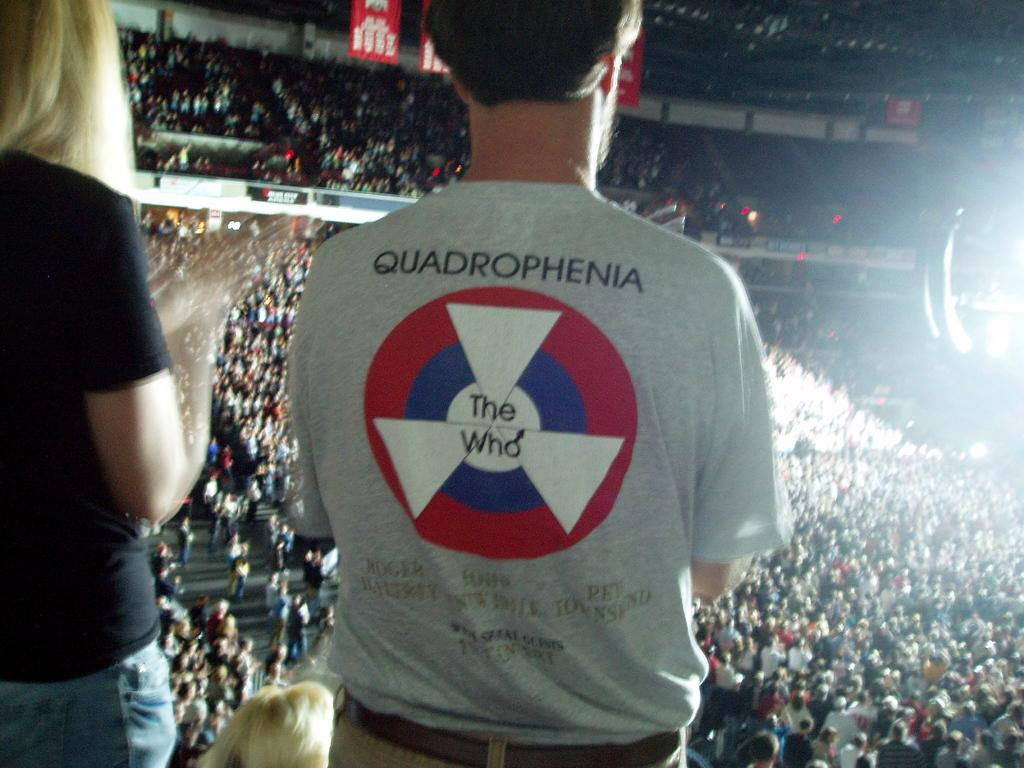<image>
Write a terse but informative summary of the picture. Man watching something while waering a shirt that says "The Who" on the back. 